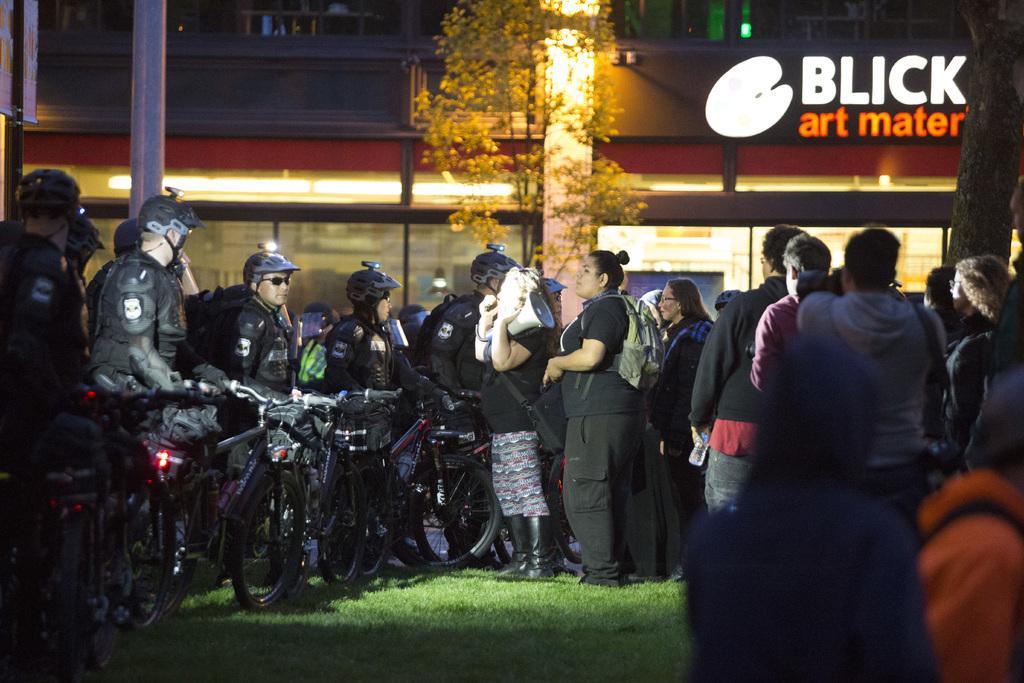In one or two sentences, can you explain what this image depicts? In this image there are a group of people some of them are wearing some helmets, and holding cycles and some of them are wearing bags. In the background there are buildings, poles, trees and lights. On the right side there is a text on a building. At the bottom there is grass. 